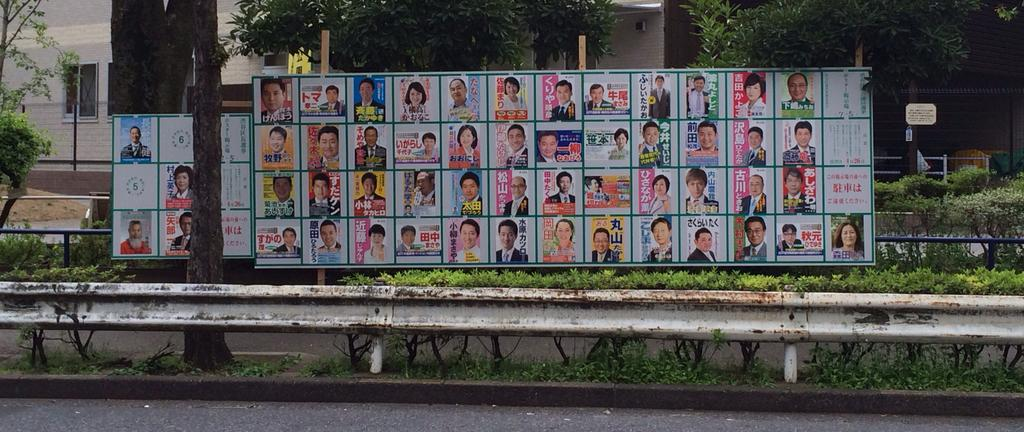What is the main subject of the image? The main subject of the image is an advertisement. What can be seen in the advertisement? The advertisement contains pictures of persons. What is visible in the background of the image? There are trees, an iron grill, a road, windows, and a building in the background of the image. What type of drug can be seen in the advertisement? There is no drug present in the advertisement or the image. What kind of machine is being used by the persons in the advertisement? There is no machine visible in the advertisement or the image. 